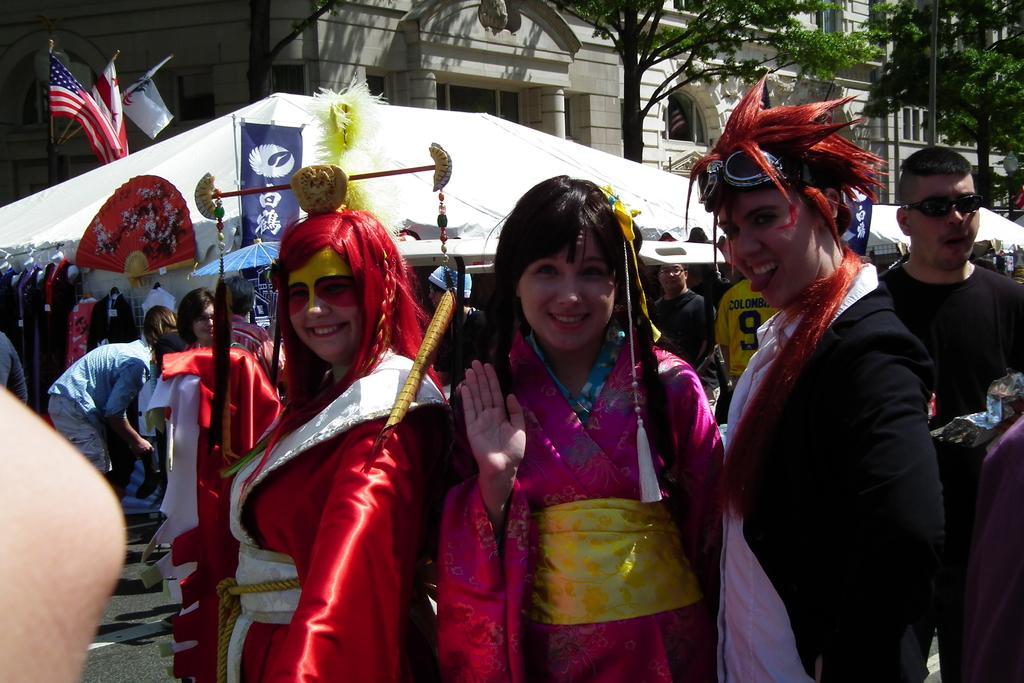Could you give a brief overview of what you see in this image? In this image there are three people standing in the center wearing colored dresses behind there is a white tent and a few flags on it, in the background there are many people, trees and a building. 